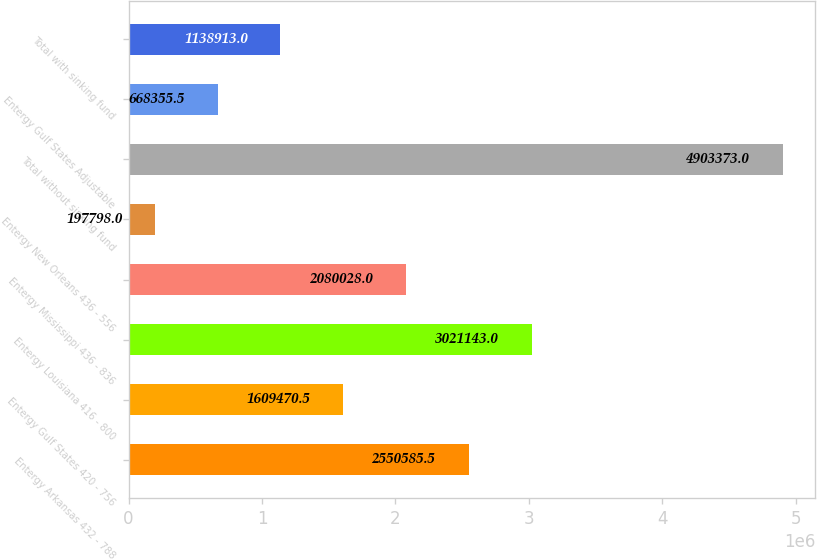Convert chart to OTSL. <chart><loc_0><loc_0><loc_500><loc_500><bar_chart><fcel>Entergy Arkansas 432 - 788<fcel>Entergy Gulf States 420 - 756<fcel>Entergy Louisiana 416 - 800<fcel>Entergy Mississippi 436 - 836<fcel>Entergy New Orleans 436 - 556<fcel>Total without sinking fund<fcel>Entergy Gulf States Adjustable<fcel>Total with sinking fund<nl><fcel>2.55059e+06<fcel>1.60947e+06<fcel>3.02114e+06<fcel>2.08003e+06<fcel>197798<fcel>4.90337e+06<fcel>668356<fcel>1.13891e+06<nl></chart> 